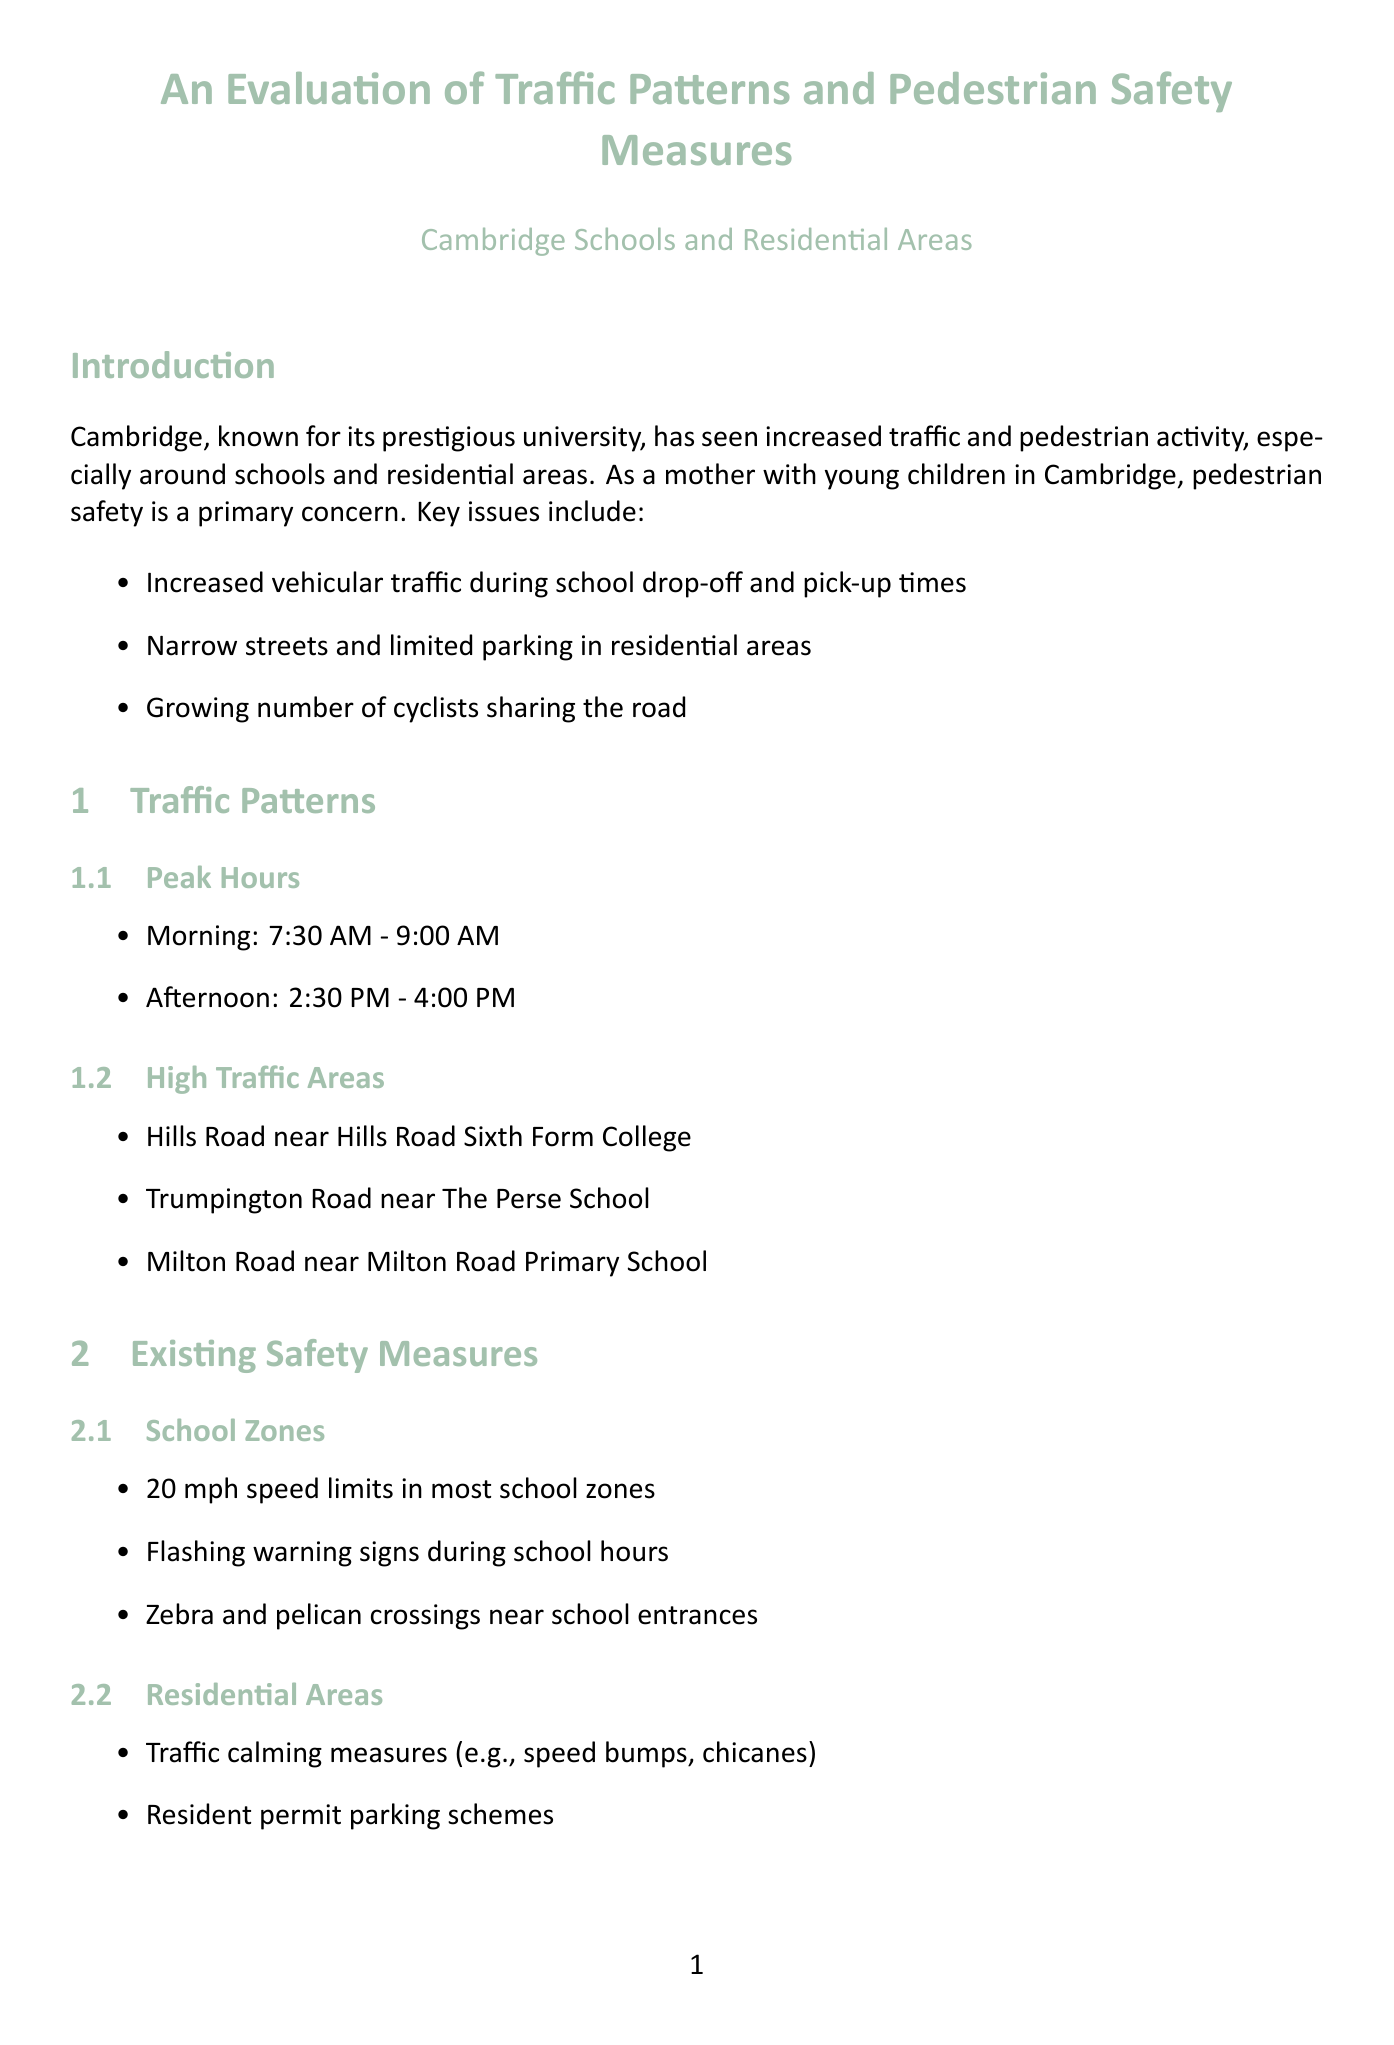What are the peak morning traffic hours? The peak morning traffic hours are specified in the traffic patterns section of the document.
Answer: 7:30 AM - 9:00 AM How many child pedestrian injuries were recorded in 2022? The document provides statistics on child pedestrian injuries from the 2022 report.
Answer: 28 What are the traffic calming measures mentioned for residential areas? The document lists specific traffic calming measures to enhance safety in residential areas.
Answer: Speed bumps, chicanes What initiative encourages walking and cycling to school? The document describes an initiative aimed at promoting safer routes for children walking and cycling to school.
Answer: Safe Routes to School Which areas have implemented 20 mph speed limits? The document identifies areas that have recently expanded 20 mph speed limits for safety.
Answer: Romsey, Castle, Abbey What is the total number of severe child pedestrian injuries in 2022? The document contains detailed statistics about the types of injuries sustained by child pedestrians in 2022.
Answer: 5 What is a top concern from parent surveys? The document summarizes parent feedback on pedestrian safety and lists main concerns identified in surveys.
Answer: Speeding vehicles near schools What type of crossings are installed with sensors? The document highlights specific safety measures that include advanced technology for pedestrian crossings.
Answer: Smart pedestrian crossings What is the summary of the conclusion? The conclusion provides a concise overview of the document's findings regarding pedestrian safety measures.
Answer: Room for improvement 